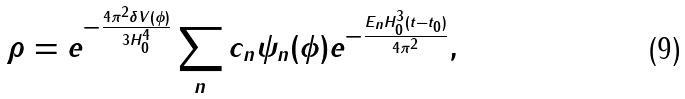<formula> <loc_0><loc_0><loc_500><loc_500>\rho = e ^ { - \frac { 4 \pi ^ { 2 } \delta V ( \phi ) } { 3 H _ { 0 } ^ { 4 } } } \sum _ { n } c _ { n } \psi _ { n } ( \phi ) e ^ { - \frac { E _ { n } H _ { 0 } ^ { 3 } ( t - t _ { 0 } ) } { 4 \pi ^ { 2 } } } ,</formula> 